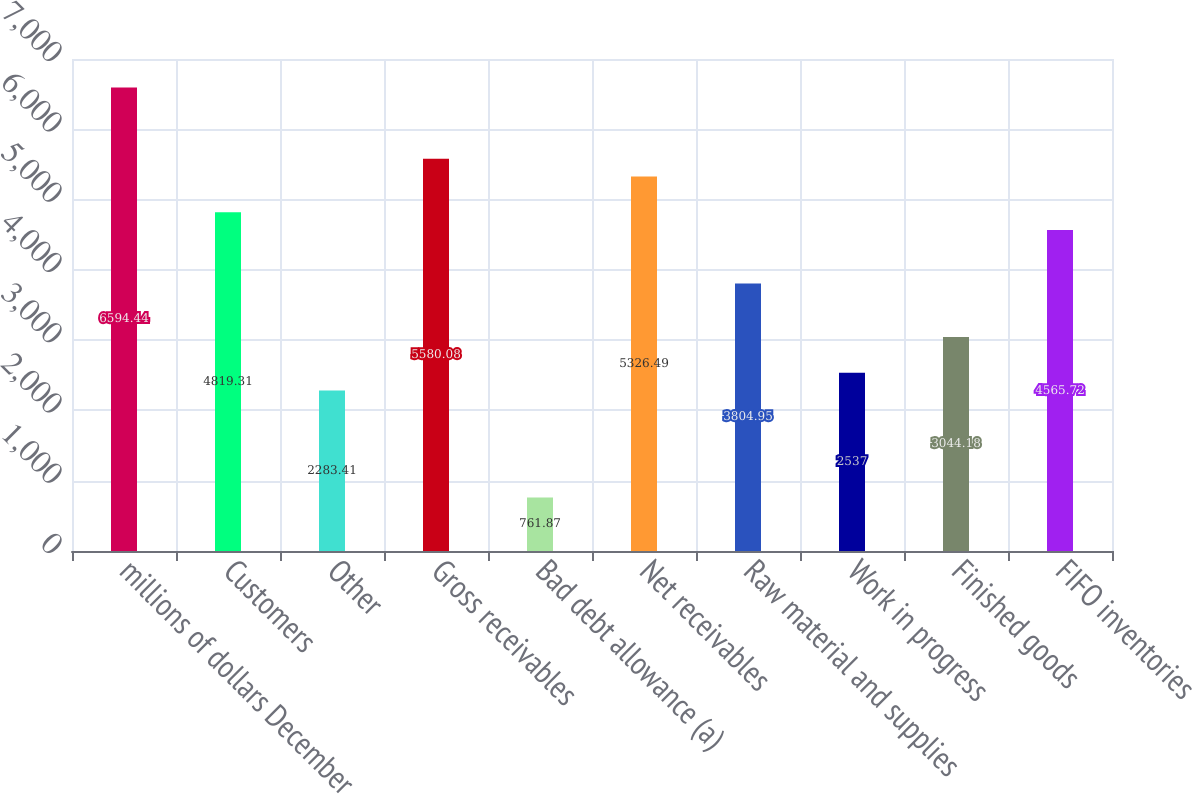Convert chart. <chart><loc_0><loc_0><loc_500><loc_500><bar_chart><fcel>millions of dollars December<fcel>Customers<fcel>Other<fcel>Gross receivables<fcel>Bad debt allowance (a)<fcel>Net receivables<fcel>Raw material and supplies<fcel>Work in progress<fcel>Finished goods<fcel>FIFO inventories<nl><fcel>6594.44<fcel>4819.31<fcel>2283.41<fcel>5580.08<fcel>761.87<fcel>5326.49<fcel>3804.95<fcel>2537<fcel>3044.18<fcel>4565.72<nl></chart> 